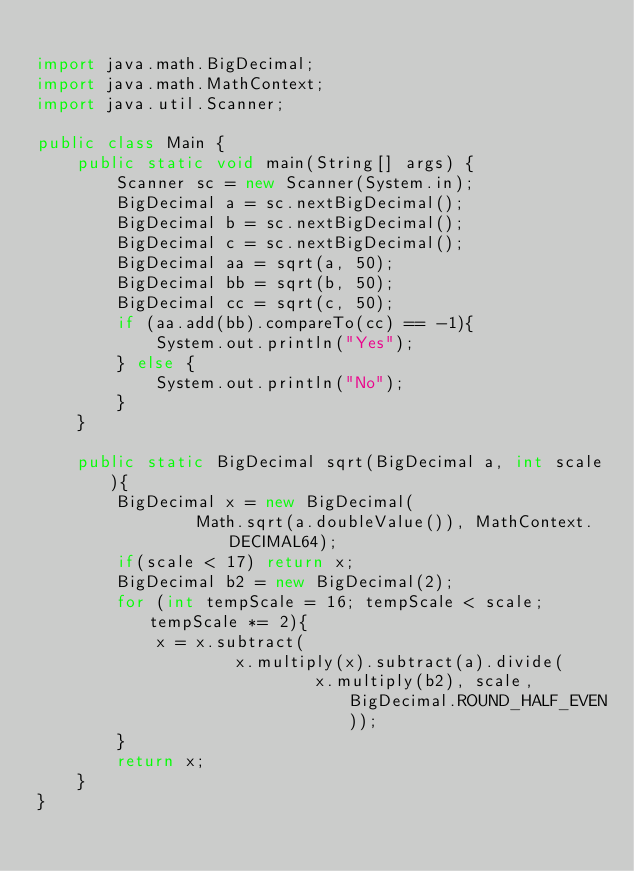<code> <loc_0><loc_0><loc_500><loc_500><_Java_>
import java.math.BigDecimal;
import java.math.MathContext;
import java.util.Scanner;

public class Main {
    public static void main(String[] args) {
        Scanner sc = new Scanner(System.in);
        BigDecimal a = sc.nextBigDecimal();
        BigDecimal b = sc.nextBigDecimal();
        BigDecimal c = sc.nextBigDecimal();
        BigDecimal aa = sqrt(a, 50);
        BigDecimal bb = sqrt(b, 50);
        BigDecimal cc = sqrt(c, 50);
        if (aa.add(bb).compareTo(cc) == -1){
            System.out.println("Yes");
        } else {
            System.out.println("No");
        }
    }

    public static BigDecimal sqrt(BigDecimal a, int scale){
        BigDecimal x = new BigDecimal(
                Math.sqrt(a.doubleValue()), MathContext.DECIMAL64);
        if(scale < 17) return x;
        BigDecimal b2 = new BigDecimal(2);
        for (int tempScale = 16; tempScale < scale; tempScale *= 2){
            x = x.subtract(
                    x.multiply(x).subtract(a).divide(
                            x.multiply(b2), scale, BigDecimal.ROUND_HALF_EVEN));
        }
        return x;
    }
}
</code> 